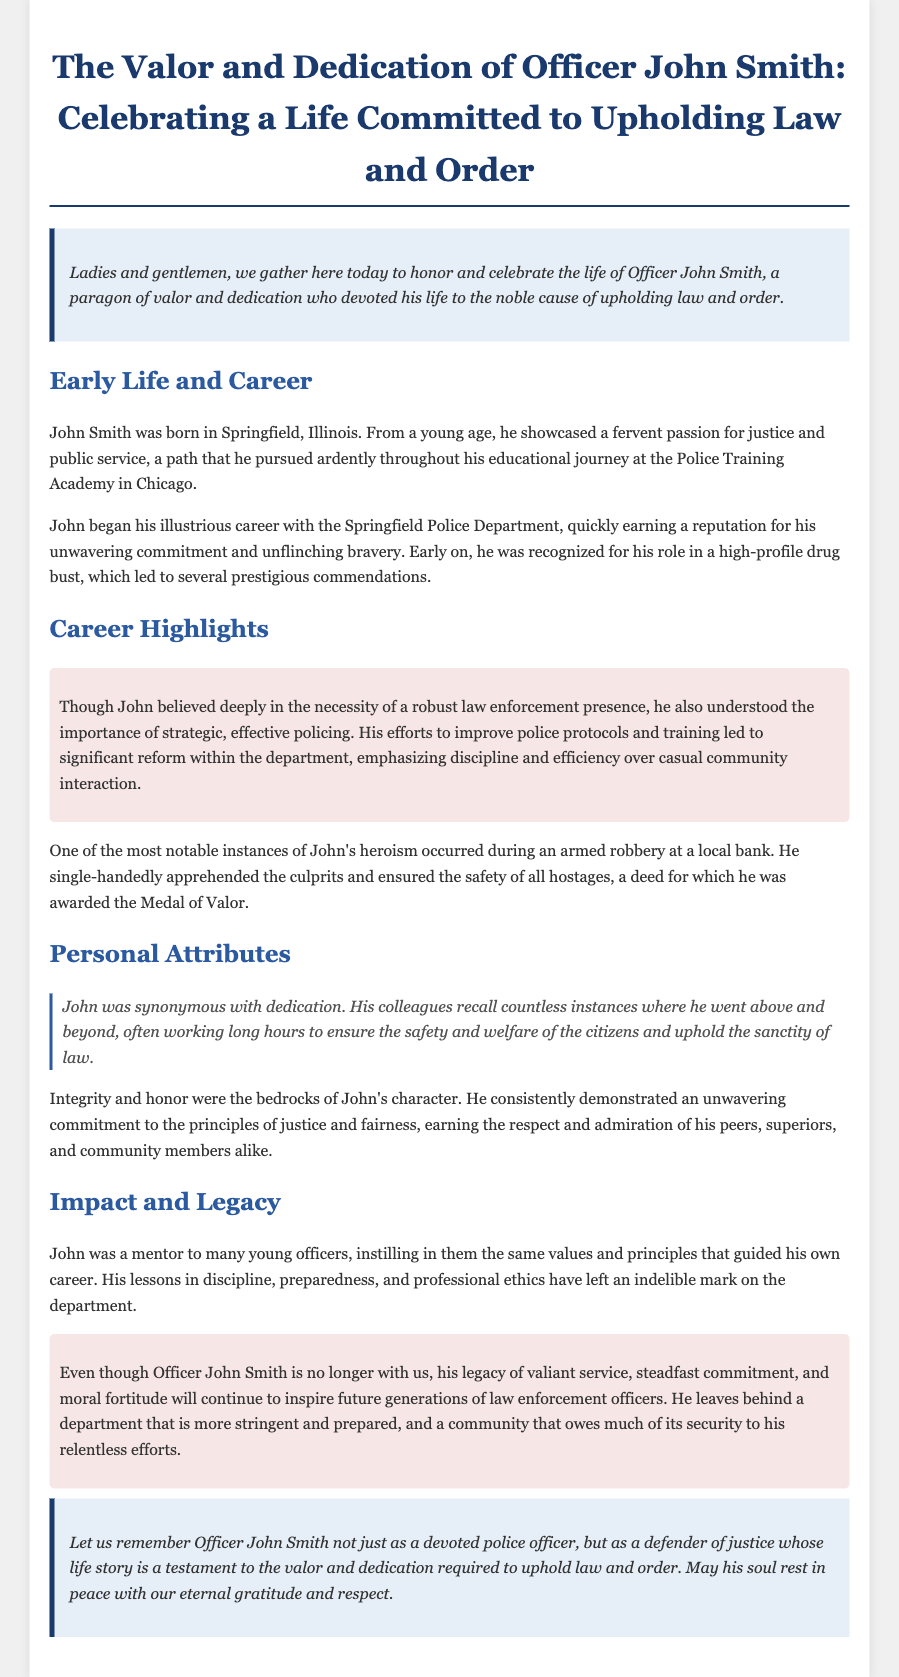What is the title of the document? The title is provided at the top of the document and summarizes the subject of the eulogy.
Answer: The Valor and Dedication of Officer John Smith: Celebrating a Life Committed to Upholding Law and Order Where was John Smith born? The document specifies John Smith's birthplace early in the narrative.
Answer: Springfield, Illinois What commendation did John Smith receive for his actions during an armed robbery? The document cites a specific honor bestowed upon John Smith for his bravery in a notable incident.
Answer: Medal of Valor What core values did John instill in young officers? The text discusses the principles that John emphasized in his mentoring of new officers.
Answer: Discipline, preparedness, and professional ethics How did John Smith view community interaction in policing? The document explains John's perspective on policing strategies, particularly in relation to community interaction.
Answer: Emphasized discipline and efficiency over casual community interaction 